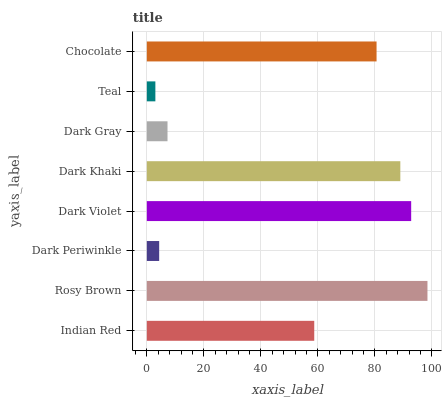Is Teal the minimum?
Answer yes or no. Yes. Is Rosy Brown the maximum?
Answer yes or no. Yes. Is Dark Periwinkle the minimum?
Answer yes or no. No. Is Dark Periwinkle the maximum?
Answer yes or no. No. Is Rosy Brown greater than Dark Periwinkle?
Answer yes or no. Yes. Is Dark Periwinkle less than Rosy Brown?
Answer yes or no. Yes. Is Dark Periwinkle greater than Rosy Brown?
Answer yes or no. No. Is Rosy Brown less than Dark Periwinkle?
Answer yes or no. No. Is Chocolate the high median?
Answer yes or no. Yes. Is Indian Red the low median?
Answer yes or no. Yes. Is Dark Violet the high median?
Answer yes or no. No. Is Dark Periwinkle the low median?
Answer yes or no. No. 